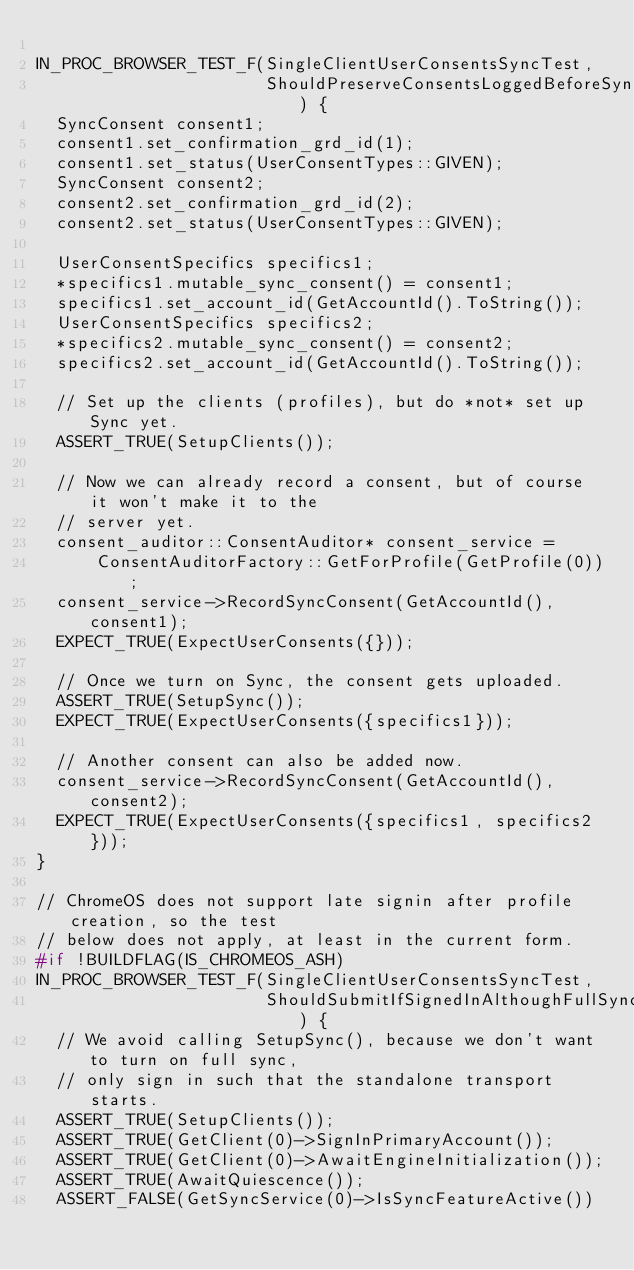<code> <loc_0><loc_0><loc_500><loc_500><_C++_>
IN_PROC_BROWSER_TEST_F(SingleClientUserConsentsSyncTest,
                       ShouldPreserveConsentsLoggedBeforeSyncSetup) {
  SyncConsent consent1;
  consent1.set_confirmation_grd_id(1);
  consent1.set_status(UserConsentTypes::GIVEN);
  SyncConsent consent2;
  consent2.set_confirmation_grd_id(2);
  consent2.set_status(UserConsentTypes::GIVEN);

  UserConsentSpecifics specifics1;
  *specifics1.mutable_sync_consent() = consent1;
  specifics1.set_account_id(GetAccountId().ToString());
  UserConsentSpecifics specifics2;
  *specifics2.mutable_sync_consent() = consent2;
  specifics2.set_account_id(GetAccountId().ToString());

  // Set up the clients (profiles), but do *not* set up Sync yet.
  ASSERT_TRUE(SetupClients());

  // Now we can already record a consent, but of course it won't make it to the
  // server yet.
  consent_auditor::ConsentAuditor* consent_service =
      ConsentAuditorFactory::GetForProfile(GetProfile(0));
  consent_service->RecordSyncConsent(GetAccountId(), consent1);
  EXPECT_TRUE(ExpectUserConsents({}));

  // Once we turn on Sync, the consent gets uploaded.
  ASSERT_TRUE(SetupSync());
  EXPECT_TRUE(ExpectUserConsents({specifics1}));

  // Another consent can also be added now.
  consent_service->RecordSyncConsent(GetAccountId(), consent2);
  EXPECT_TRUE(ExpectUserConsents({specifics1, specifics2}));
}

// ChromeOS does not support late signin after profile creation, so the test
// below does not apply, at least in the current form.
#if !BUILDFLAG(IS_CHROMEOS_ASH)
IN_PROC_BROWSER_TEST_F(SingleClientUserConsentsSyncTest,
                       ShouldSubmitIfSignedInAlthoughFullSyncNotEnabled) {
  // We avoid calling SetupSync(), because we don't want to turn on full sync,
  // only sign in such that the standalone transport starts.
  ASSERT_TRUE(SetupClients());
  ASSERT_TRUE(GetClient(0)->SignInPrimaryAccount());
  ASSERT_TRUE(GetClient(0)->AwaitEngineInitialization());
  ASSERT_TRUE(AwaitQuiescence());
  ASSERT_FALSE(GetSyncService(0)->IsSyncFeatureActive())</code> 